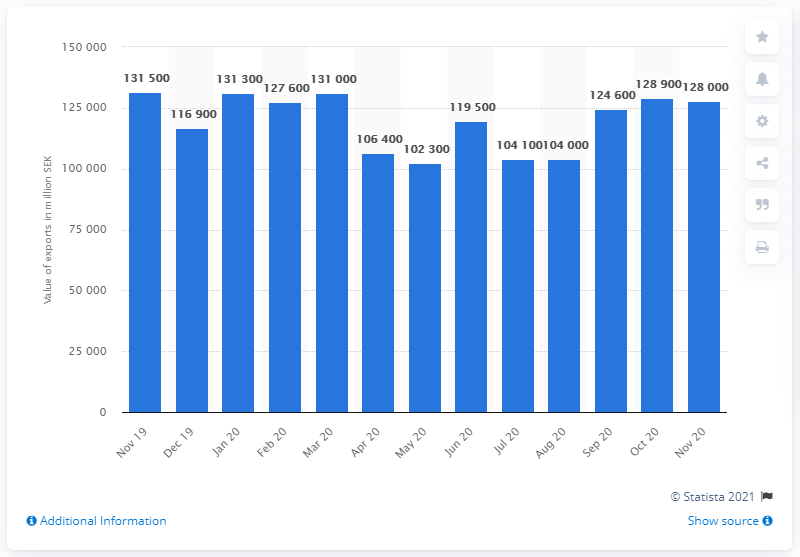Outline some significant characteristics in this image. The value of exports in Swedish kronor in November 2020 was 128,000. 